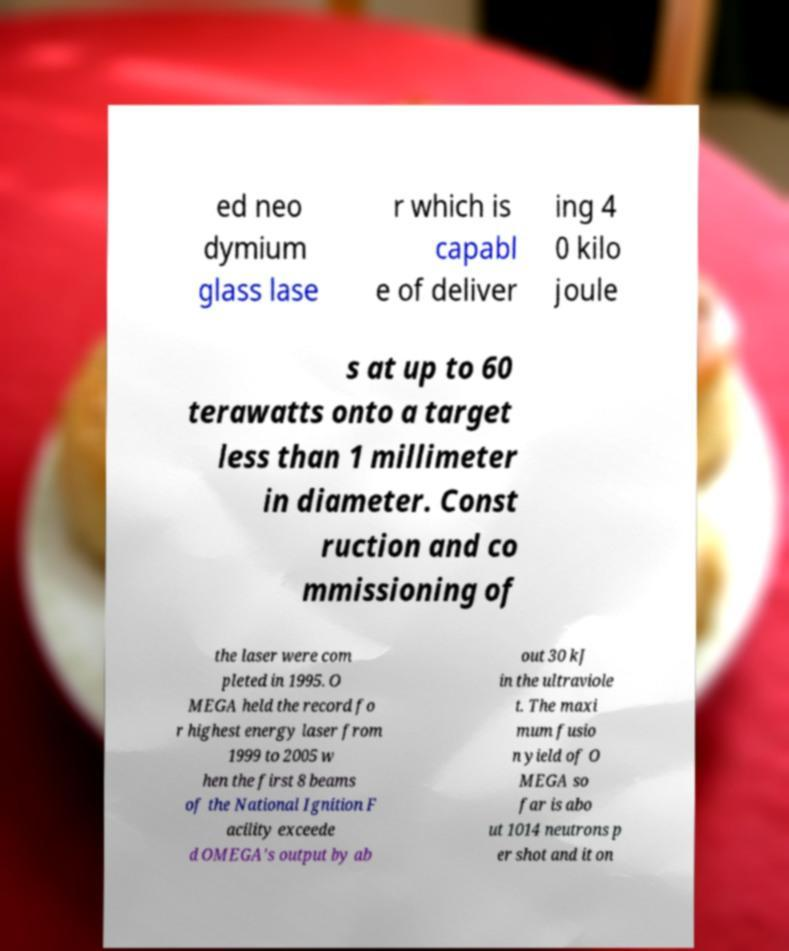What messages or text are displayed in this image? I need them in a readable, typed format. ed neo dymium glass lase r which is capabl e of deliver ing 4 0 kilo joule s at up to 60 terawatts onto a target less than 1 millimeter in diameter. Const ruction and co mmissioning of the laser were com pleted in 1995. O MEGA held the record fo r highest energy laser from 1999 to 2005 w hen the first 8 beams of the National Ignition F acility exceede d OMEGA's output by ab out 30 kJ in the ultraviole t. The maxi mum fusio n yield of O MEGA so far is abo ut 1014 neutrons p er shot and it on 